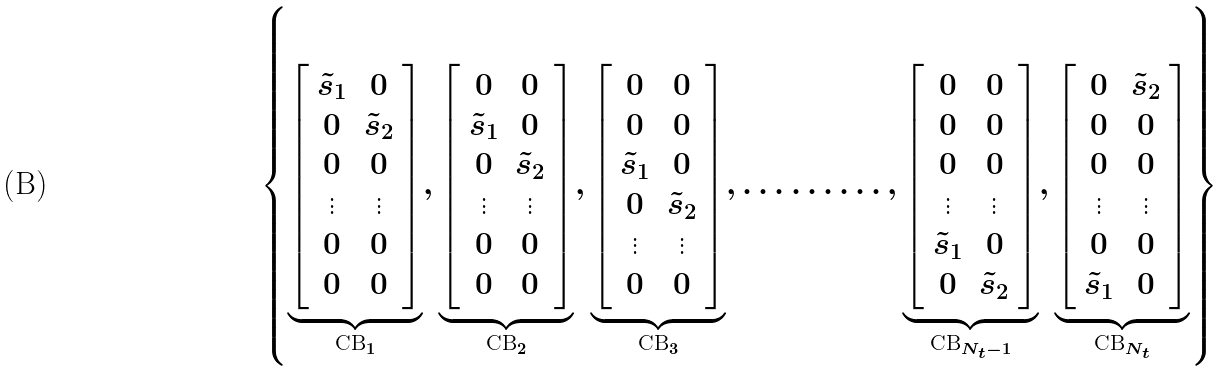<formula> <loc_0><loc_0><loc_500><loc_500>\left \{ \underbrace { \left [ \begin{array} { c c } { \tilde { s } } _ { 1 } & 0 \\ 0 & { \tilde { s } } _ { 2 } \\ 0 & 0 \\ \vdots & \vdots \\ 0 & 0 \\ 0 & 0 \end{array} \right ] } _ { \text {CB} _ { 1 } } , \underbrace { \left [ \begin{array} { c c } 0 & 0 \\ { \tilde { s } } _ { 1 } & 0 \\ 0 & { \tilde { s } } _ { 2 } \\ \vdots & \vdots \\ 0 & 0 \\ 0 & 0 \end{array} \right ] } _ { \text {CB} _ { 2 } } , \underbrace { \left [ \begin{array} { c c } 0 & 0 \\ 0 & 0 \\ { \tilde { s } } _ { 1 } & 0 \\ 0 & { \tilde { s } } _ { 2 } \\ \vdots & \vdots \\ 0 & 0 \end{array} \right ] } _ { \text {CB} _ { 3 } } , \hdots \hdots \hdots , \underbrace { \left [ \begin{array} { c c } 0 & 0 \\ 0 & 0 \\ 0 & 0 \\ \vdots & \vdots \\ { \tilde { s } } _ { 1 } & 0 \\ 0 & { \tilde { s } } _ { 2 } \end{array} \right ] } _ { \text {CB} _ { N _ { t } - 1 } } , \underbrace { \left [ \begin{array} { c c } 0 & { \tilde { s } } _ { 2 } \\ 0 & 0 \\ 0 & 0 \\ \vdots & \vdots \\ 0 & 0 \\ { \tilde { s } } _ { 1 } & 0 \end{array} \right ] } _ { \text {CB} _ { N _ { t } } } \right \}</formula> 